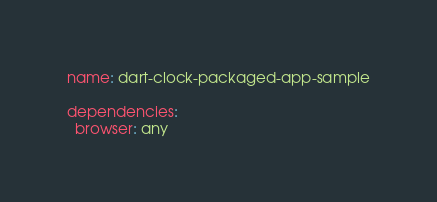Convert code to text. <code><loc_0><loc_0><loc_500><loc_500><_YAML_>name: dart-clock-packaged-app-sample

dependencies:
  browser: any
</code> 